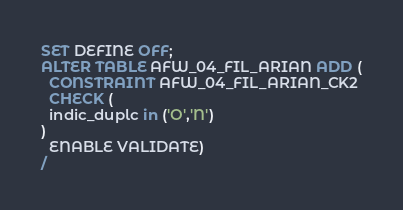<code> <loc_0><loc_0><loc_500><loc_500><_SQL_>SET DEFINE OFF;
ALTER TABLE AFW_04_FIL_ARIAN ADD (
  CONSTRAINT AFW_04_FIL_ARIAN_CK2
  CHECK (
  indic_duplc in ('O','N')
)
  ENABLE VALIDATE)
/
</code> 